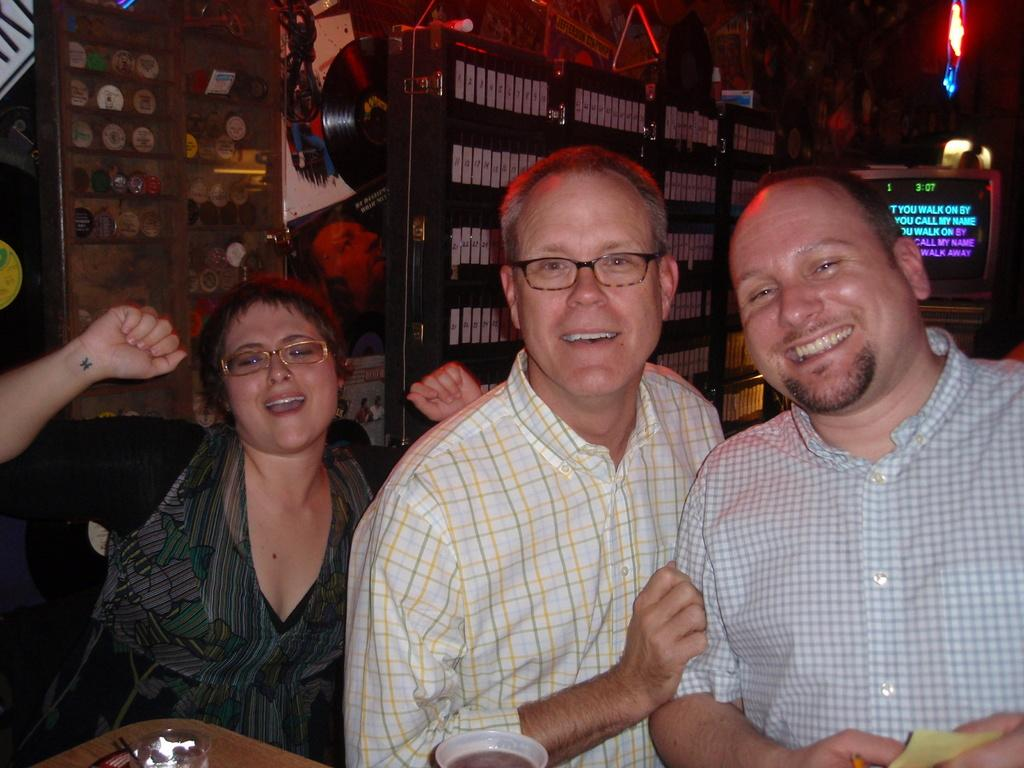How many people are in the image? There are three people in the image. What is the facial expression of the people in the image? The people are smiling. What can be seen in the background of the image? There is a screen and other objects visible in the background of the image. Is there a bridge visible in the image? No, there is no bridge present in the image. How do the people in the image grip the objects they are holding? There is no information about the people holding objects or their grip in the image. 